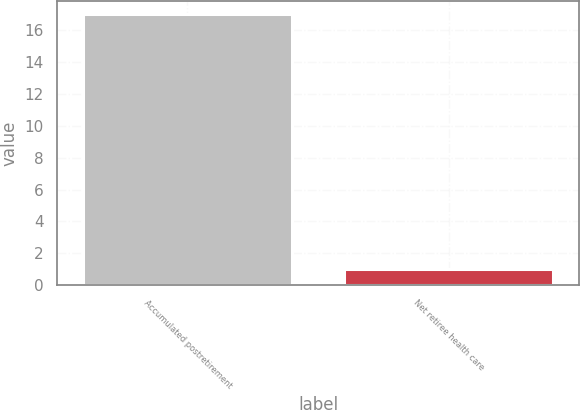Convert chart. <chart><loc_0><loc_0><loc_500><loc_500><bar_chart><fcel>Accumulated postretirement<fcel>Net retiree health care<nl><fcel>17<fcel>1<nl></chart> 